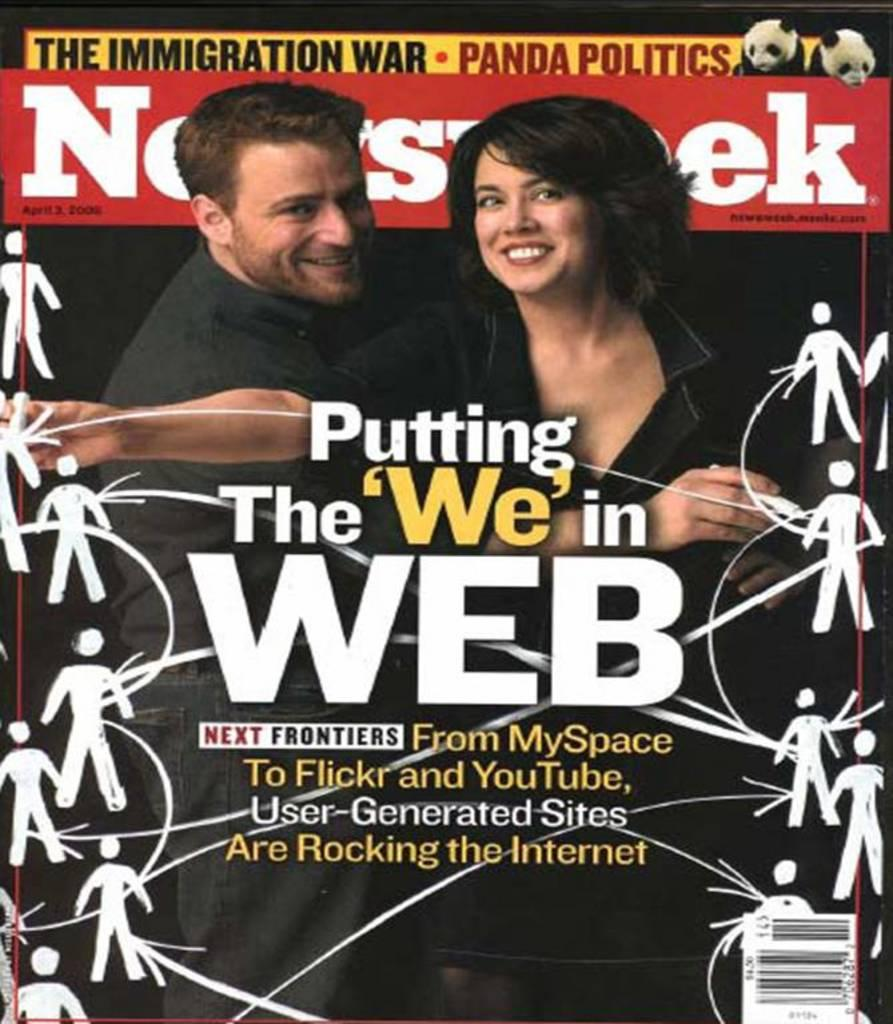Provide a one-sentence caption for the provided image. An edition of Newsweek magazine featuring stories about user generated websites. 